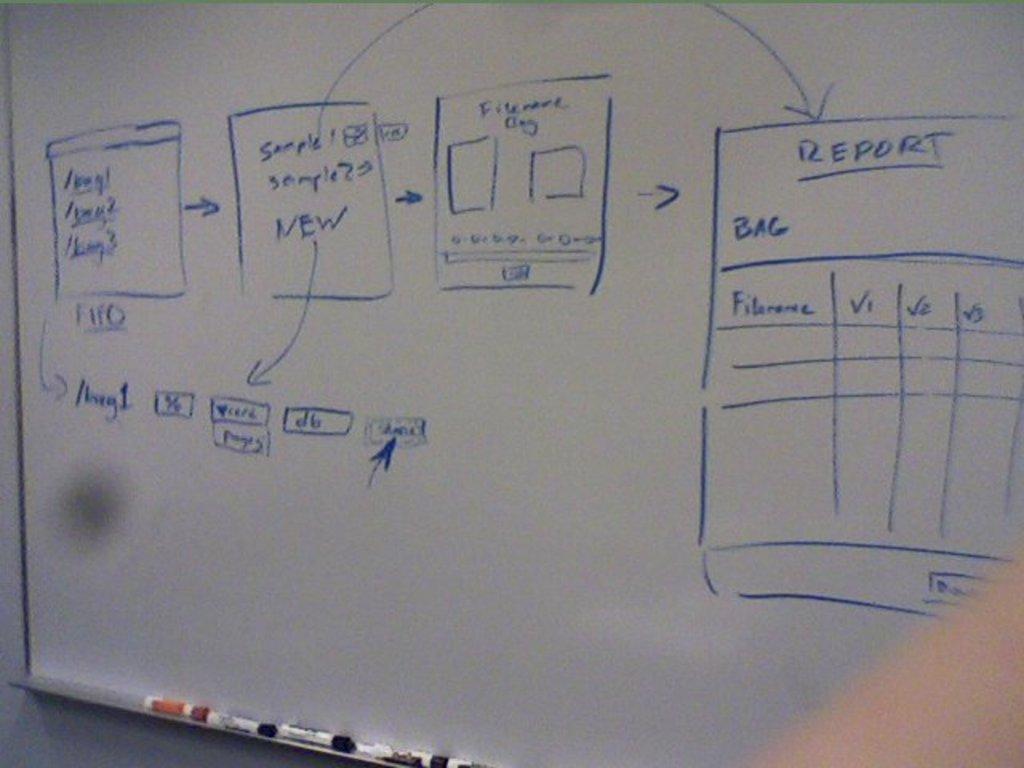What is the last box's title?
Offer a terse response. Report. 